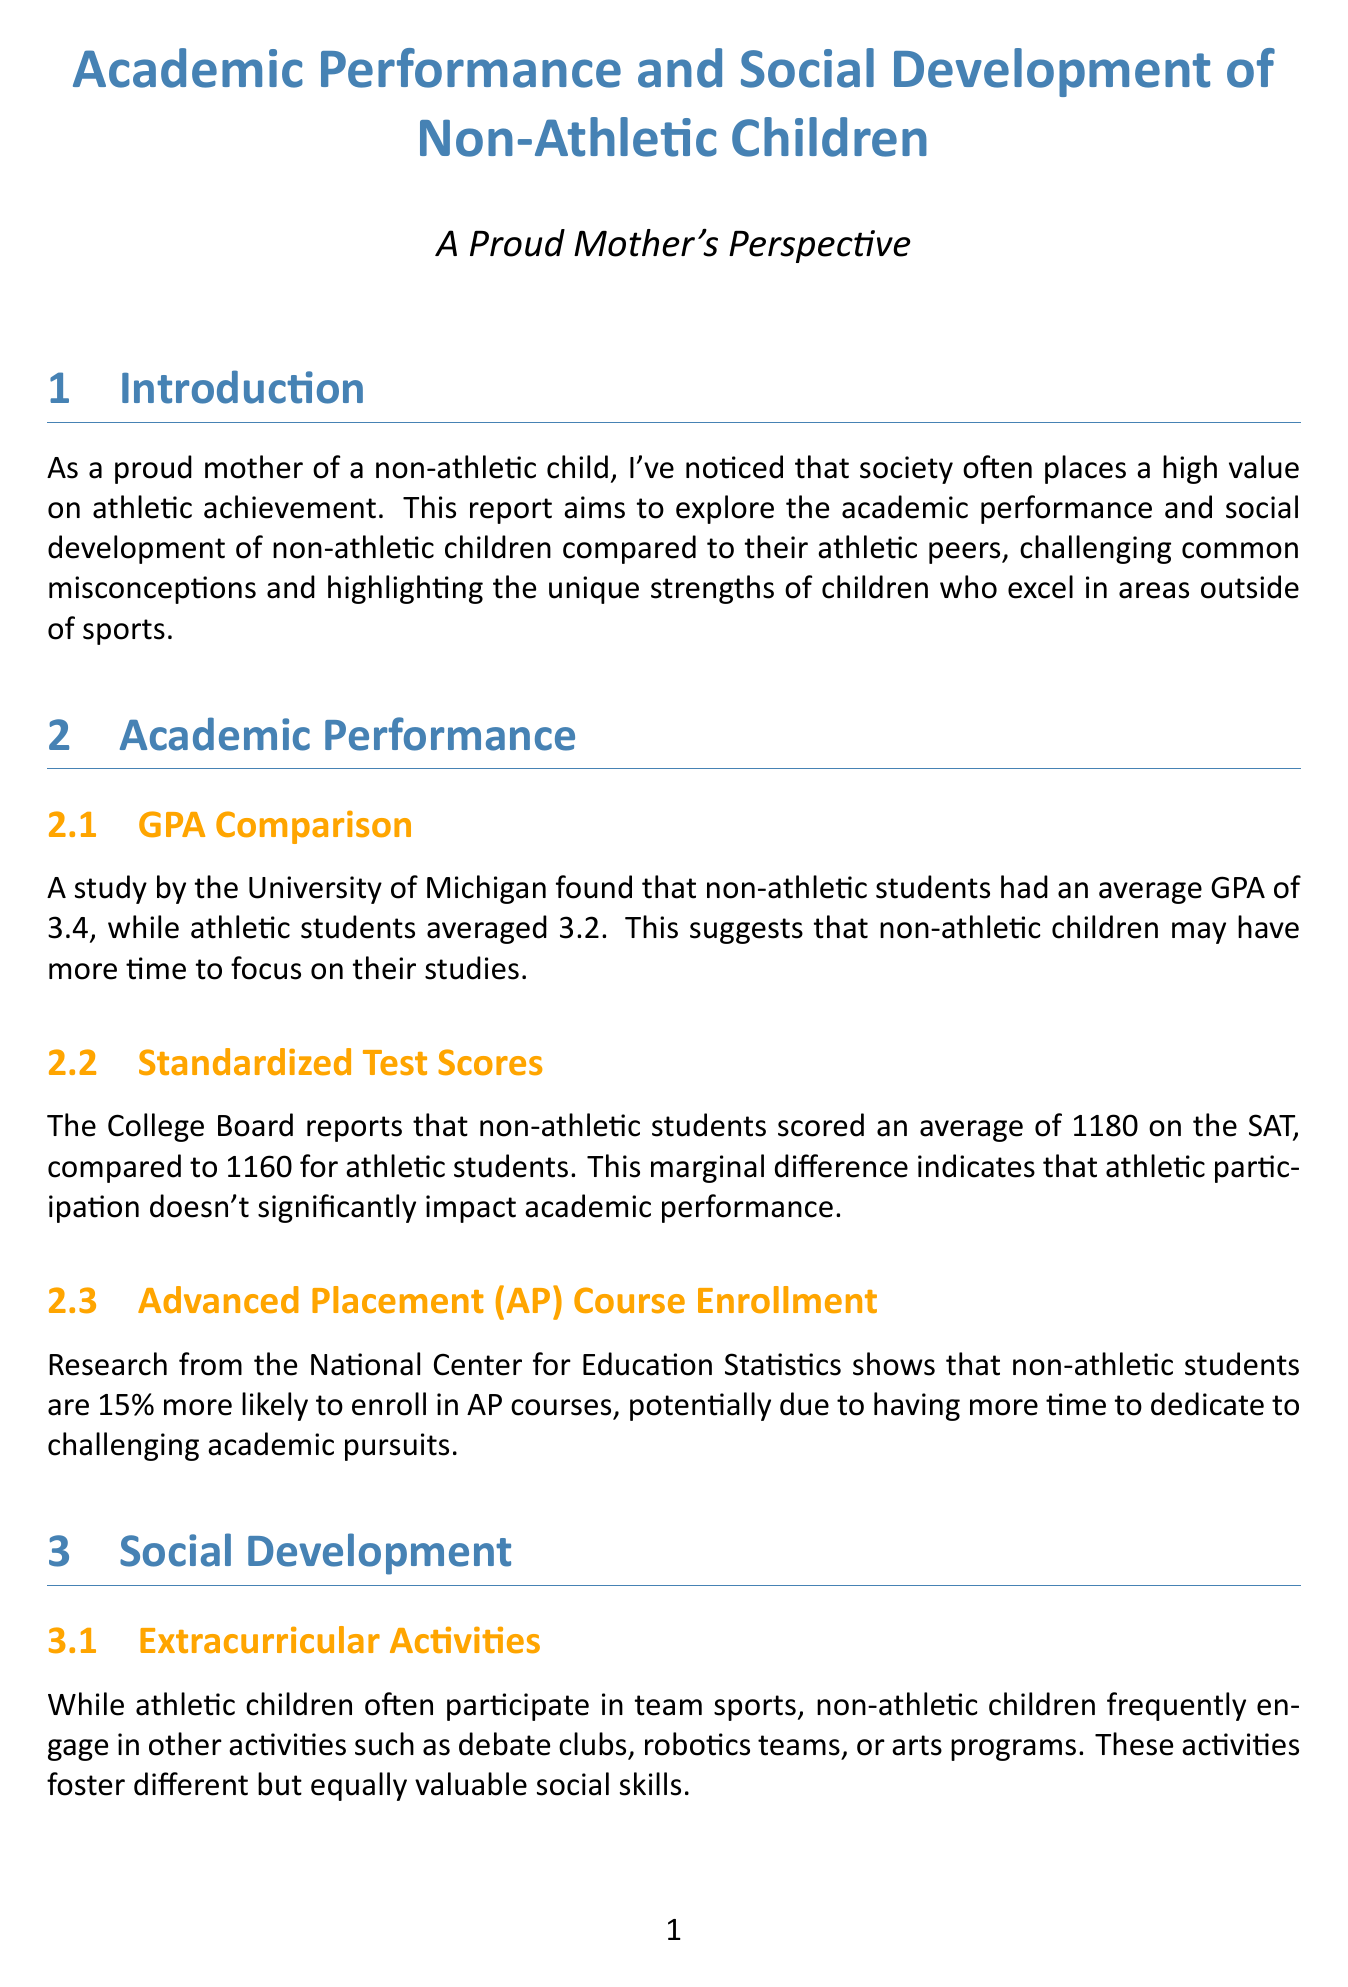What is the average GPA of non-athletic students? The document states that non-athletic students had an average GPA of 3.4, while athletic students averaged 3.2.
Answer: 3.4 What is the SAT score difference between non-athletic and athletic students? The College Board reports that non-athletic students scored an average of 1180 on the SAT, compared to 1160 for athletic students.
Answer: 20 What percentage more likely are non-athletic students to enroll in AP courses? Research from the National Center for Education Statistics shows that non-athletic students are 15% more likely to enroll in AP courses.
Answer: 15% Which extracurricular activities do non-athletic children often engage in? The document mentions that non-athletic children engage in activities such as debate clubs, robotics teams, or arts programs.
Answer: Debate clubs, robotics teams, arts programs What do non-athletic children tend to form based on shared interests? A study published in the Journal of Youth and Adolescence found that non-athletic children tend to form deeper, more intimate friendships.
Answer: Deeper friendships Who won the Google Science Fair for her innovative AI project? The case study describes Emily Chen, a 16-year-old non-athletic student excelling in computer programming.
Answer: Emily Chen What resource is recommended for fostering a growth mindset? The document suggests "Mindset: The New Psychology of Success" by Carol S. Dweck for parents looking to foster a growth mindset.
Answer: Mindset: The New Psychology of Success What does the document highlight regarding non-athletic children's talents? The conclusion emphasizes that non-athletic children can thrive academically and socially, matching or surpassing athletic peers.
Answer: Thrive academically and socially Which university conducted a study finding no significant difference in career success? The longitudinal study cited in the document was conducted by the University of California, Berkeley.
Answer: University of California, Berkeley 